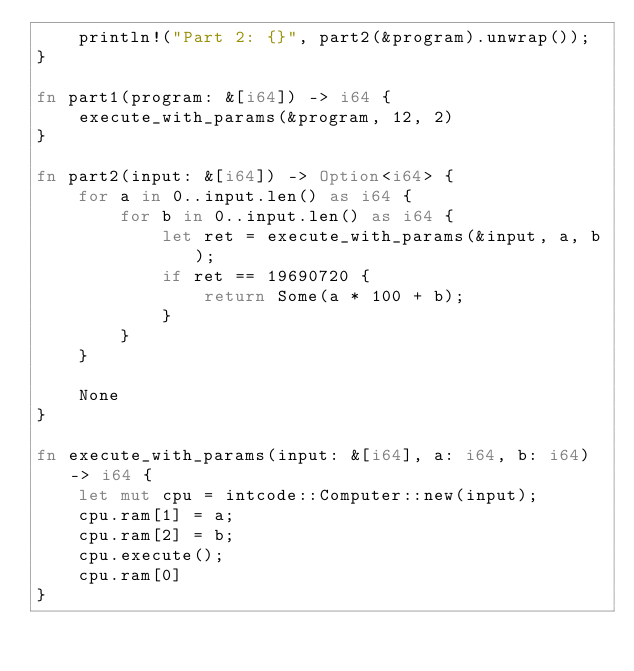<code> <loc_0><loc_0><loc_500><loc_500><_Rust_>    println!("Part 2: {}", part2(&program).unwrap());
}

fn part1(program: &[i64]) -> i64 {
    execute_with_params(&program, 12, 2)
}

fn part2(input: &[i64]) -> Option<i64> {
    for a in 0..input.len() as i64 {
        for b in 0..input.len() as i64 {
            let ret = execute_with_params(&input, a, b);
            if ret == 19690720 {
                return Some(a * 100 + b);
            }
        }
    }

    None
}

fn execute_with_params(input: &[i64], a: i64, b: i64) -> i64 {
    let mut cpu = intcode::Computer::new(input);
    cpu.ram[1] = a;
    cpu.ram[2] = b;
    cpu.execute();
    cpu.ram[0]
}
</code> 